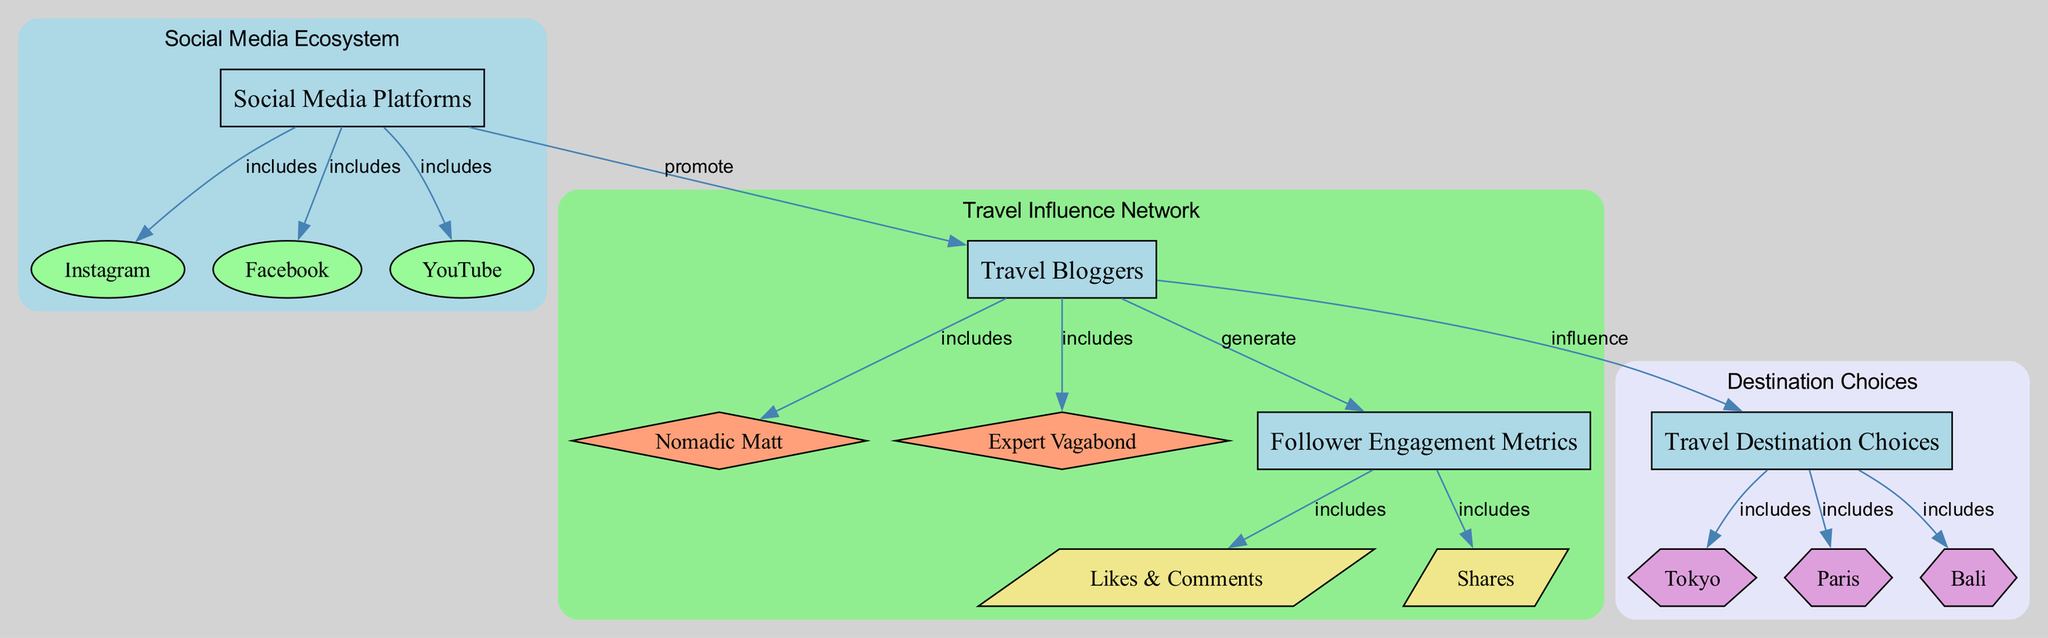What types of categories are represented in the diagram? The diagram includes three main categories: Social Media Platforms, Travel Bloggers, and Travel Destination Choices. By examining the nodes listed, we can identify these categories explicitly.
Answer: Social Media Platforms, Travel Bloggers, Travel Destination Choices How many social media platforms are included in the diagram? The diagram shows three social media platforms: Instagram, Facebook, and YouTube. This can be determined by counting the nodes connected to the "social_media" node under the Social Media Ecosystem category.
Answer: 3 Which travel blogger is associated with social media promotion? The "travel_bloggers" node connects directly to the "social_media" node, indicating that travel bloggers promote social media. From the list of bloggers, both Nomadic Matt and Expert Vagabond are available, but they are collectively associated with this relationship.
Answer: travel bloggers What relationships exist between travel bloggers and travel destinations? The diagram indicates that travel bloggers influence travel destination choices, as seen in the edge connecting "travel_bloggers" to "destination_choices." This shows a direct influence, meaning that travel bloggers affect which destinations travelers might choose.
Answer: influence What follower engagement metrics are generated by travel bloggers? The diagram outlines that follower engagement metrics include Likes & Comments and Shares. This can be noted from the direct relationship where "travel_bloggers" generates "follower_metrics," which are internally subdivided into the two types of metrics.
Answer: Likes & Comments, Shares Which destination is included in the travel destination choices? The travel destination choices include three specific destinations: Tokyo, Paris, and Bali. This can be confirmed by examining the connections from the "destination_choices" node to these destinations.
Answer: Tokyo, Paris, Bali Among the social media platforms, which one is directly linked to travel bloggers? The diagram shows that travel bloggers are promoted on social media platforms, specifically highlighting Instagram as a main platform that highlights engagement with travel content. Therefore, Instagram serves a key role in this promotion.
Answer: Instagram What is the total number of edges in the diagram? The diagram lists several edges that represent relationships between nodes. By counting all the connections labeled in the edges section, we can find the total number of edges, which includes connections for social media platforms, travel bloggers, engagement metrics, and destination choices.
Answer: 12 